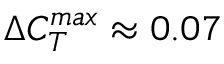<formula> <loc_0><loc_0><loc_500><loc_500>\Delta C _ { T } ^ { \max } \approx 0 . 0 7</formula> 